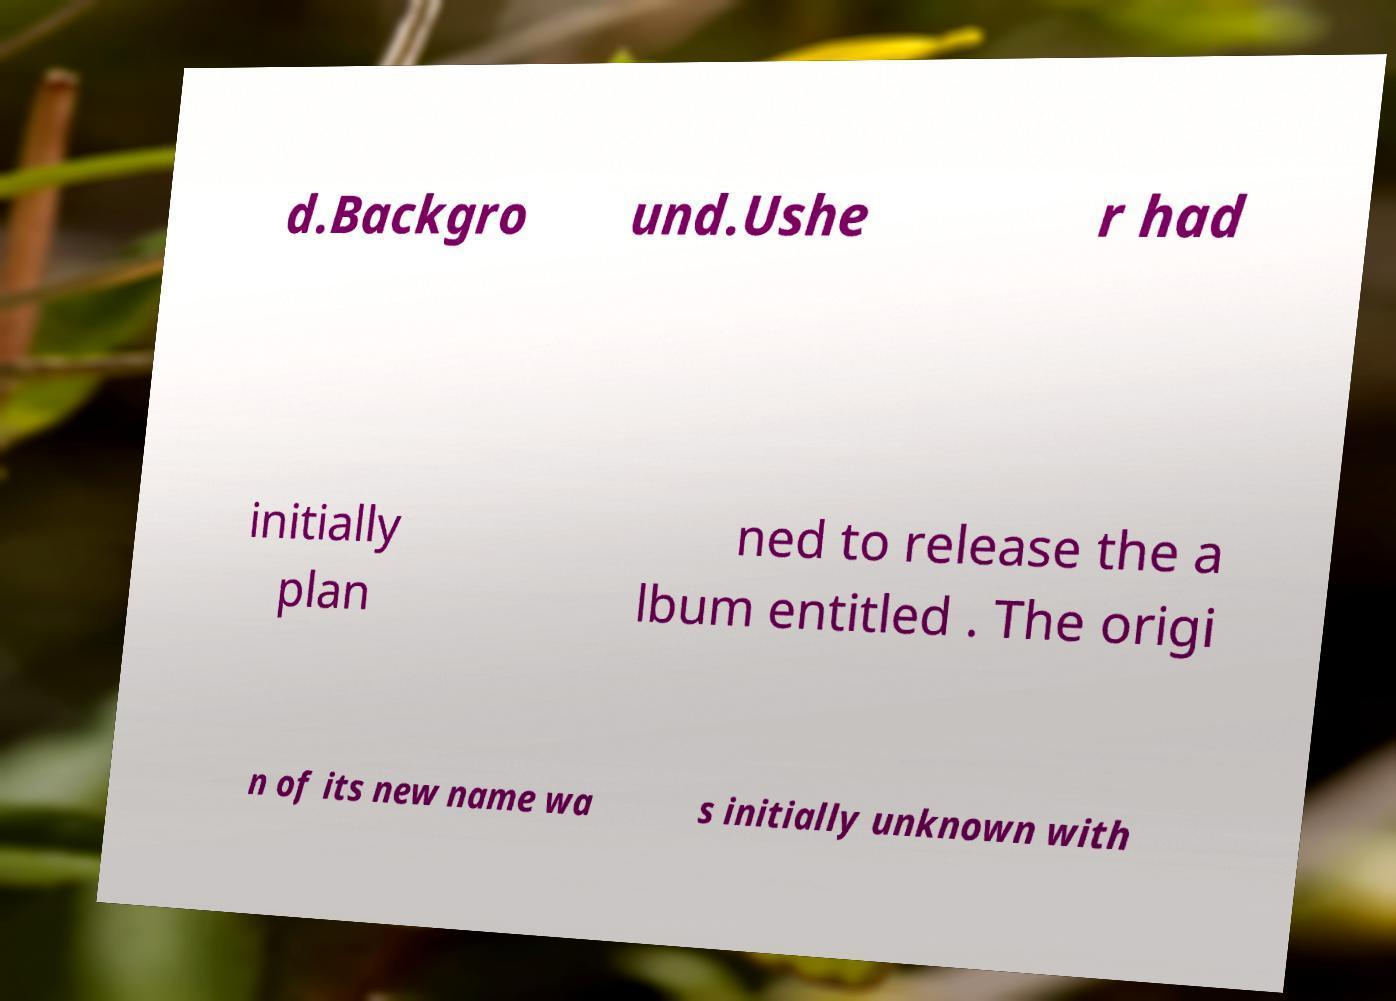I need the written content from this picture converted into text. Can you do that? d.Backgro und.Ushe r had initially plan ned to release the a lbum entitled . The origi n of its new name wa s initially unknown with 